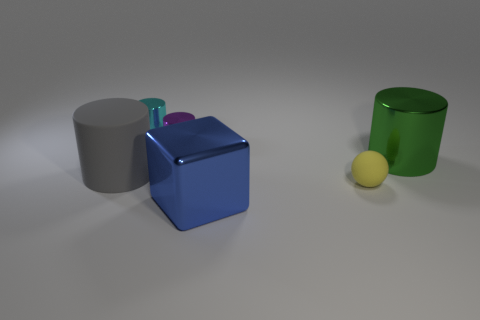Add 3 tiny green shiny things. How many objects exist? 9 Subtract all cyan cylinders. How many cylinders are left? 3 Subtract all small cyan metallic cylinders. How many cylinders are left? 3 Subtract all cylinders. How many objects are left? 2 Subtract all brown cylinders. How many blue spheres are left? 0 Add 3 yellow objects. How many yellow objects are left? 4 Add 1 large cyan matte cylinders. How many large cyan matte cylinders exist? 1 Subtract 1 purple cylinders. How many objects are left? 5 Subtract all brown blocks. Subtract all purple balls. How many blocks are left? 1 Subtract all gray cylinders. Subtract all red metallic spheres. How many objects are left? 5 